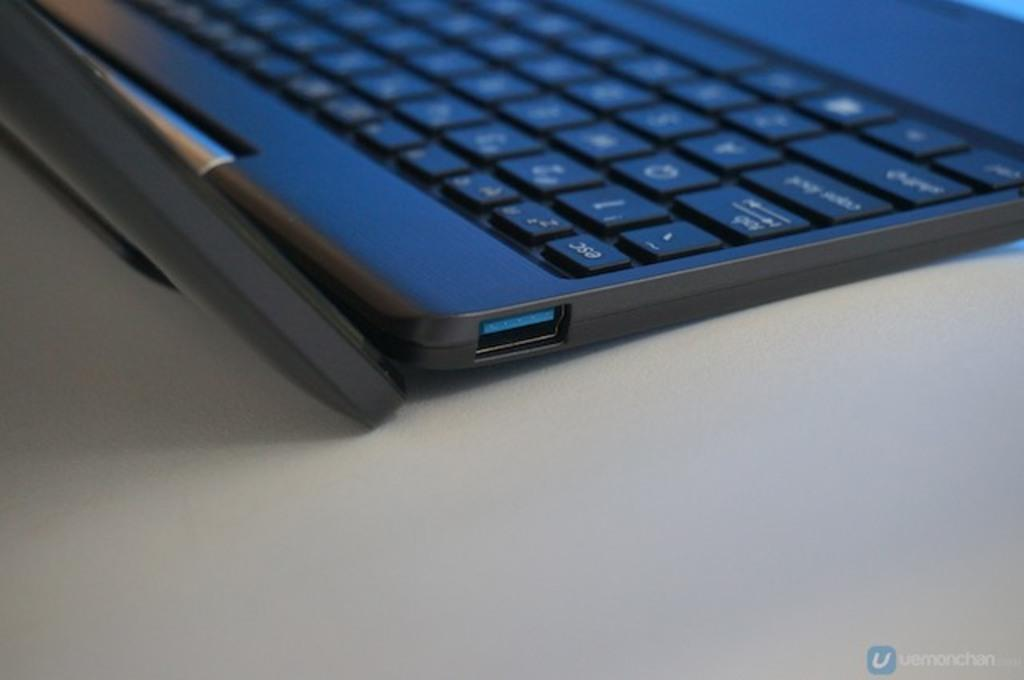<image>
Render a clear and concise summary of the photo. A close-up of a portion of a laptop with the ESC key visible. 